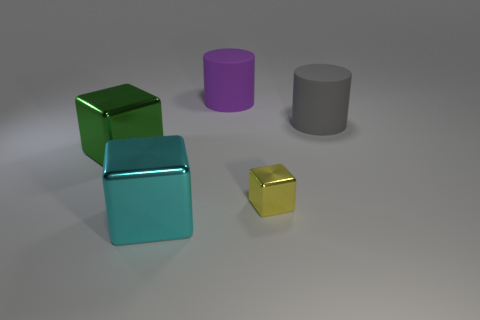What material is the large cyan block? Based on the image's lighting and reflections, the large cyan block appears to be of a smooth, reflective surface, typically indicative of a metal material, which is also consistent with common materials used in computer-generated imagery for such reflections. 